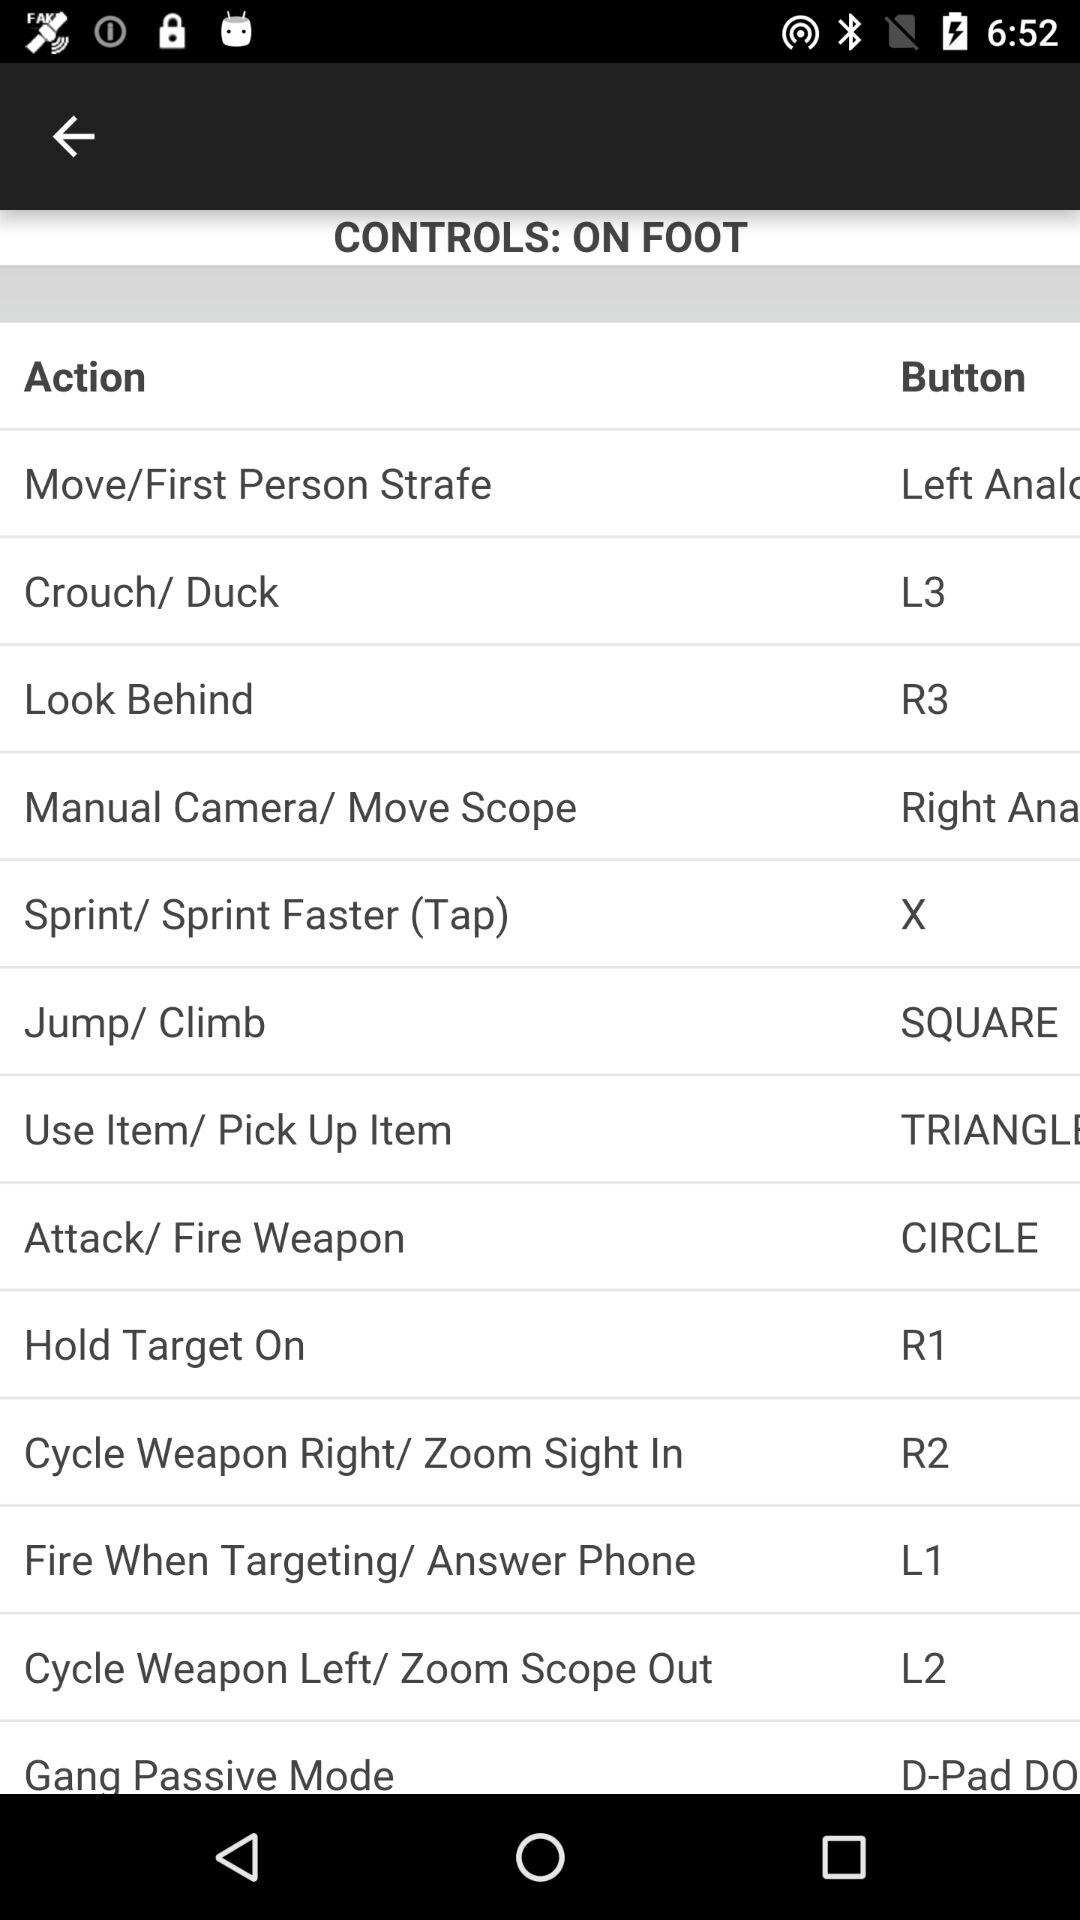Which button performs the "Look behind" action? The button that performs the "Look behind" action is "R3". 